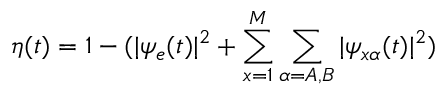<formula> <loc_0><loc_0><loc_500><loc_500>\eta ( t ) = 1 - ( | \psi _ { e } ( t ) | ^ { 2 } + \sum _ { \substack { x = 1 } } ^ { M } \sum _ { \substack { \alpha = A , B } } | \psi _ { x \alpha } ( t ) | ^ { 2 } )</formula> 